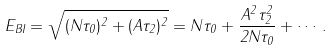Convert formula to latex. <formula><loc_0><loc_0><loc_500><loc_500>E _ { B I } = \sqrt { ( N \tau _ { 0 } ) ^ { 2 } + ( A \tau _ { 2 } ) ^ { 2 } } = N \tau _ { 0 } + \frac { A ^ { 2 } \tau _ { 2 } ^ { 2 } } { 2 N \tau _ { 0 } } + \cdots .</formula> 